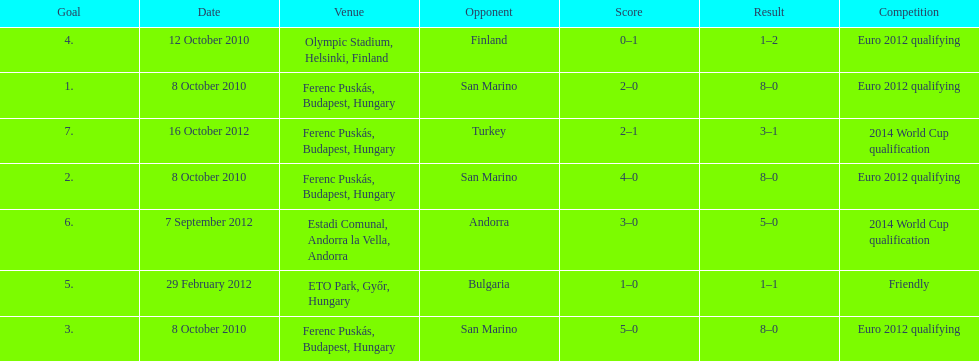When did ádám szalai make his first international goal? 8 October 2010. 